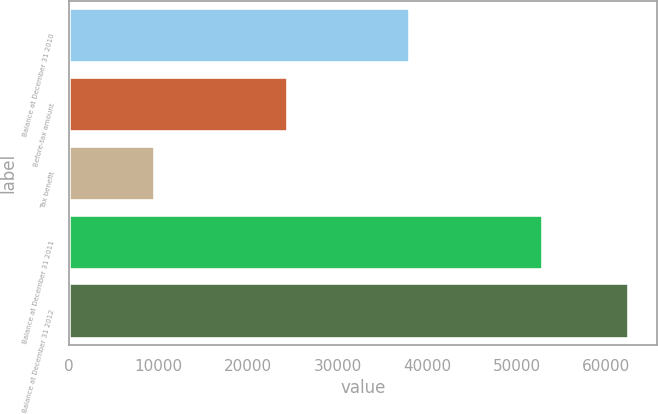<chart> <loc_0><loc_0><loc_500><loc_500><bar_chart><fcel>Balance at December 31 2010<fcel>Before-tax amount<fcel>Tax benefit<fcel>Balance at December 31 2011<fcel>Balance at December 31 2012<nl><fcel>38077<fcel>24497<fcel>9605<fcel>52969<fcel>62502<nl></chart> 